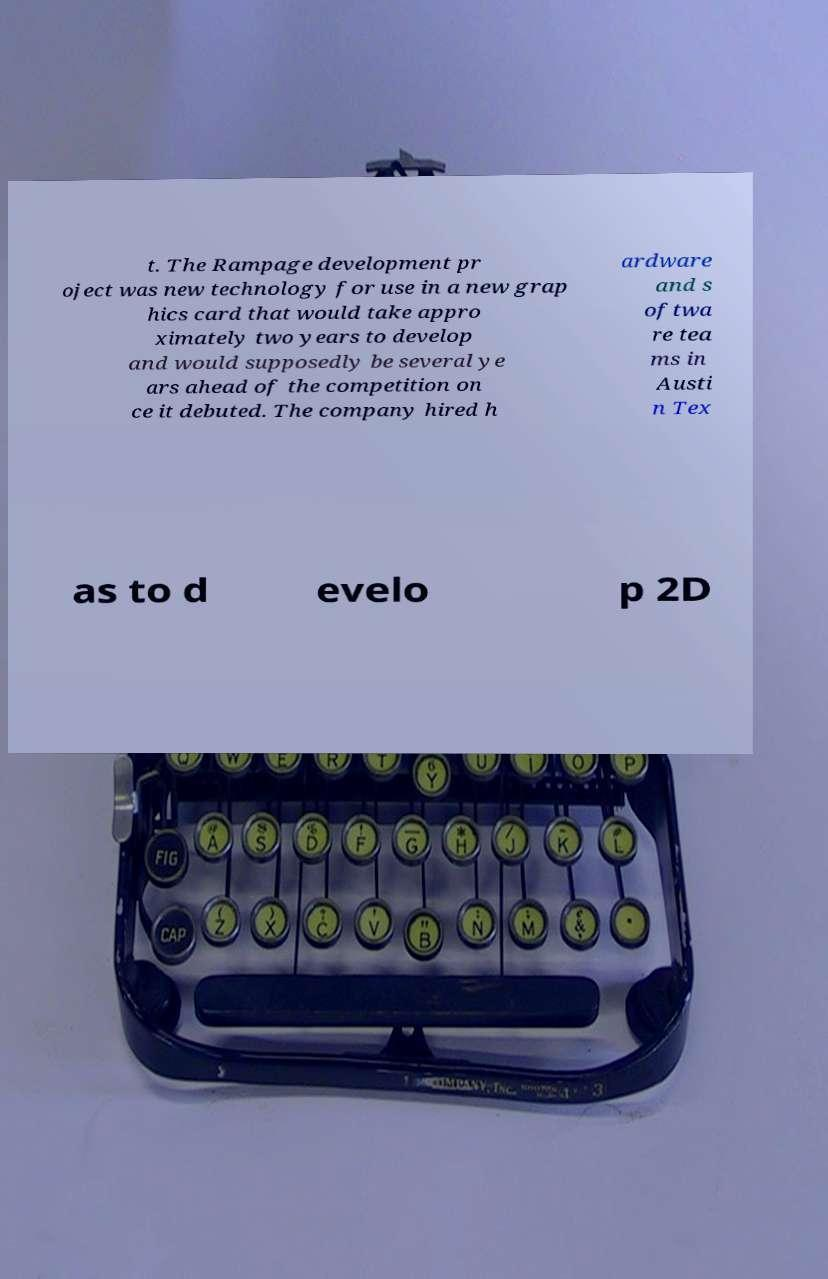For documentation purposes, I need the text within this image transcribed. Could you provide that? t. The Rampage development pr oject was new technology for use in a new grap hics card that would take appro ximately two years to develop and would supposedly be several ye ars ahead of the competition on ce it debuted. The company hired h ardware and s oftwa re tea ms in Austi n Tex as to d evelo p 2D 